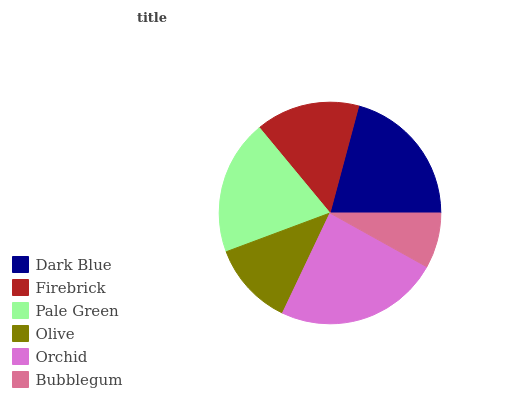Is Bubblegum the minimum?
Answer yes or no. Yes. Is Orchid the maximum?
Answer yes or no. Yes. Is Firebrick the minimum?
Answer yes or no. No. Is Firebrick the maximum?
Answer yes or no. No. Is Dark Blue greater than Firebrick?
Answer yes or no. Yes. Is Firebrick less than Dark Blue?
Answer yes or no. Yes. Is Firebrick greater than Dark Blue?
Answer yes or no. No. Is Dark Blue less than Firebrick?
Answer yes or no. No. Is Pale Green the high median?
Answer yes or no. Yes. Is Firebrick the low median?
Answer yes or no. Yes. Is Olive the high median?
Answer yes or no. No. Is Pale Green the low median?
Answer yes or no. No. 